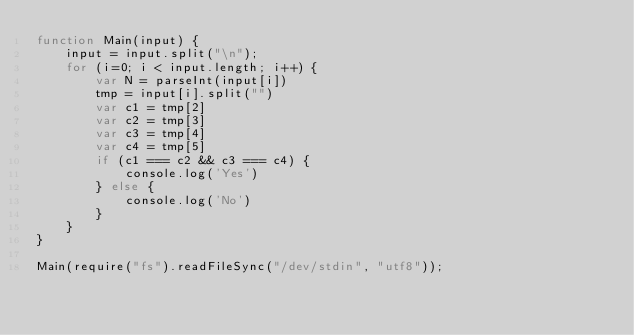<code> <loc_0><loc_0><loc_500><loc_500><_JavaScript_>function Main(input) {
    input = input.split("\n");
    for (i=0; i < input.length; i++) {
        var N = parseInt(input[i])
        tmp = input[i].split("")
        var c1 = tmp[2]
        var c2 = tmp[3]
        var c3 = tmp[4]
        var c4 = tmp[5]
        if (c1 === c2 && c3 === c4) {
            console.log('Yes')
        } else {
            console.log('No')
        }
    }
}

Main(require("fs").readFileSync("/dev/stdin", "utf8"));
</code> 